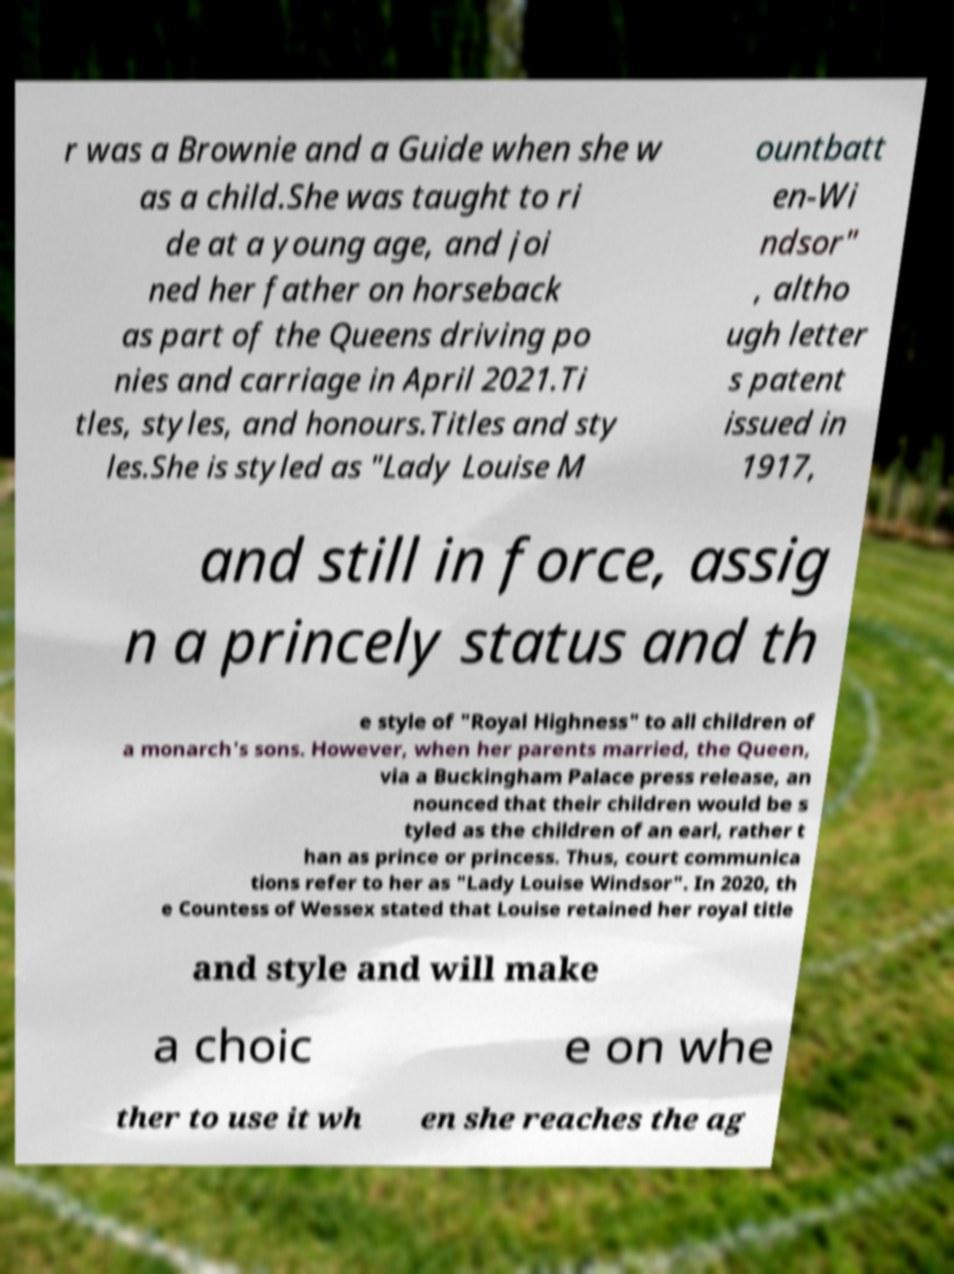For documentation purposes, I need the text within this image transcribed. Could you provide that? r was a Brownie and a Guide when she w as a child.She was taught to ri de at a young age, and joi ned her father on horseback as part of the Queens driving po nies and carriage in April 2021.Ti tles, styles, and honours.Titles and sty les.She is styled as "Lady Louise M ountbatt en-Wi ndsor" , altho ugh letter s patent issued in 1917, and still in force, assig n a princely status and th e style of "Royal Highness" to all children of a monarch's sons. However, when her parents married, the Queen, via a Buckingham Palace press release, an nounced that their children would be s tyled as the children of an earl, rather t han as prince or princess. Thus, court communica tions refer to her as "Lady Louise Windsor". In 2020, th e Countess of Wessex stated that Louise retained her royal title and style and will make a choic e on whe ther to use it wh en she reaches the ag 